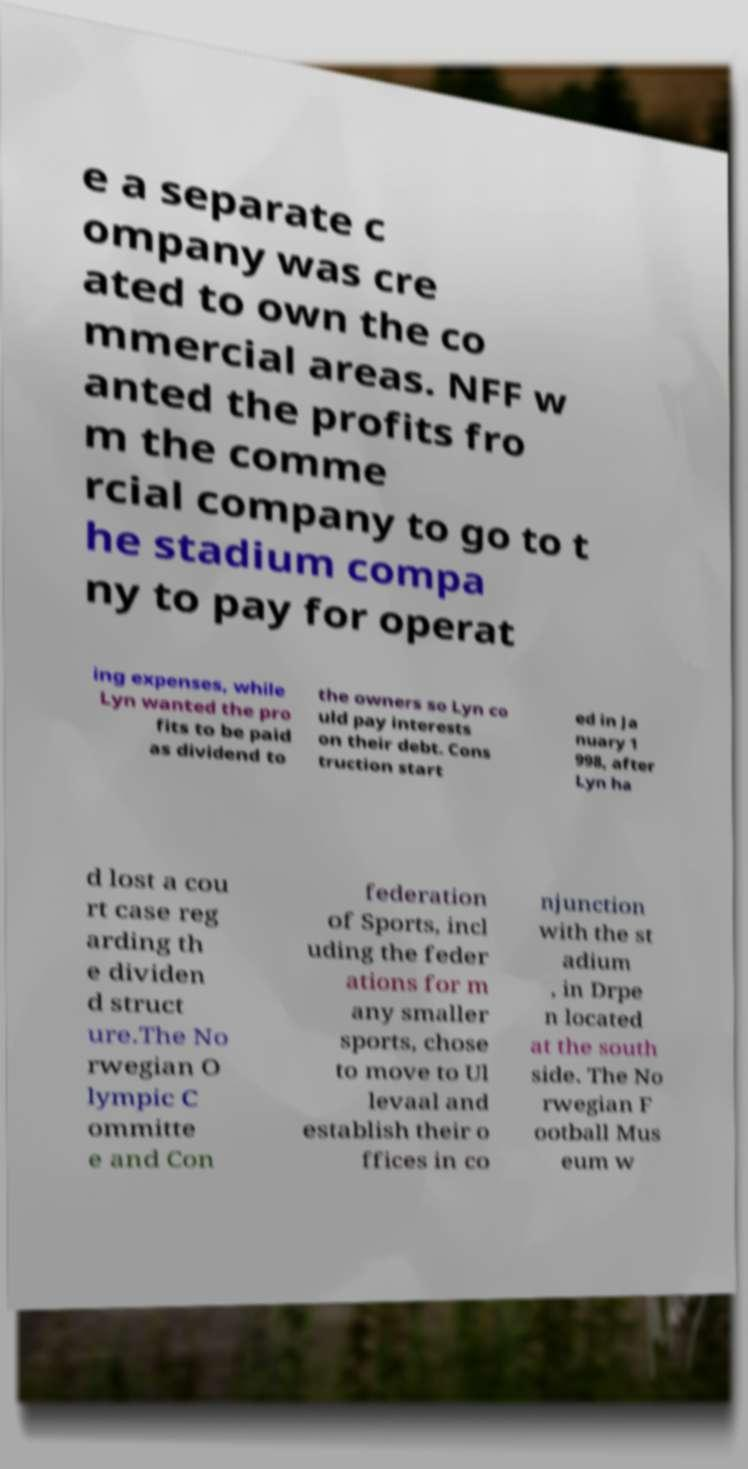What messages or text are displayed in this image? I need them in a readable, typed format. e a separate c ompany was cre ated to own the co mmercial areas. NFF w anted the profits fro m the comme rcial company to go to t he stadium compa ny to pay for operat ing expenses, while Lyn wanted the pro fits to be paid as dividend to the owners so Lyn co uld pay interests on their debt. Cons truction start ed in Ja nuary 1 998, after Lyn ha d lost a cou rt case reg arding th e dividen d struct ure.The No rwegian O lympic C ommitte e and Con federation of Sports, incl uding the feder ations for m any smaller sports, chose to move to Ul levaal and establish their o ffices in co njunction with the st adium , in Drpe n located at the south side. The No rwegian F ootball Mus eum w 